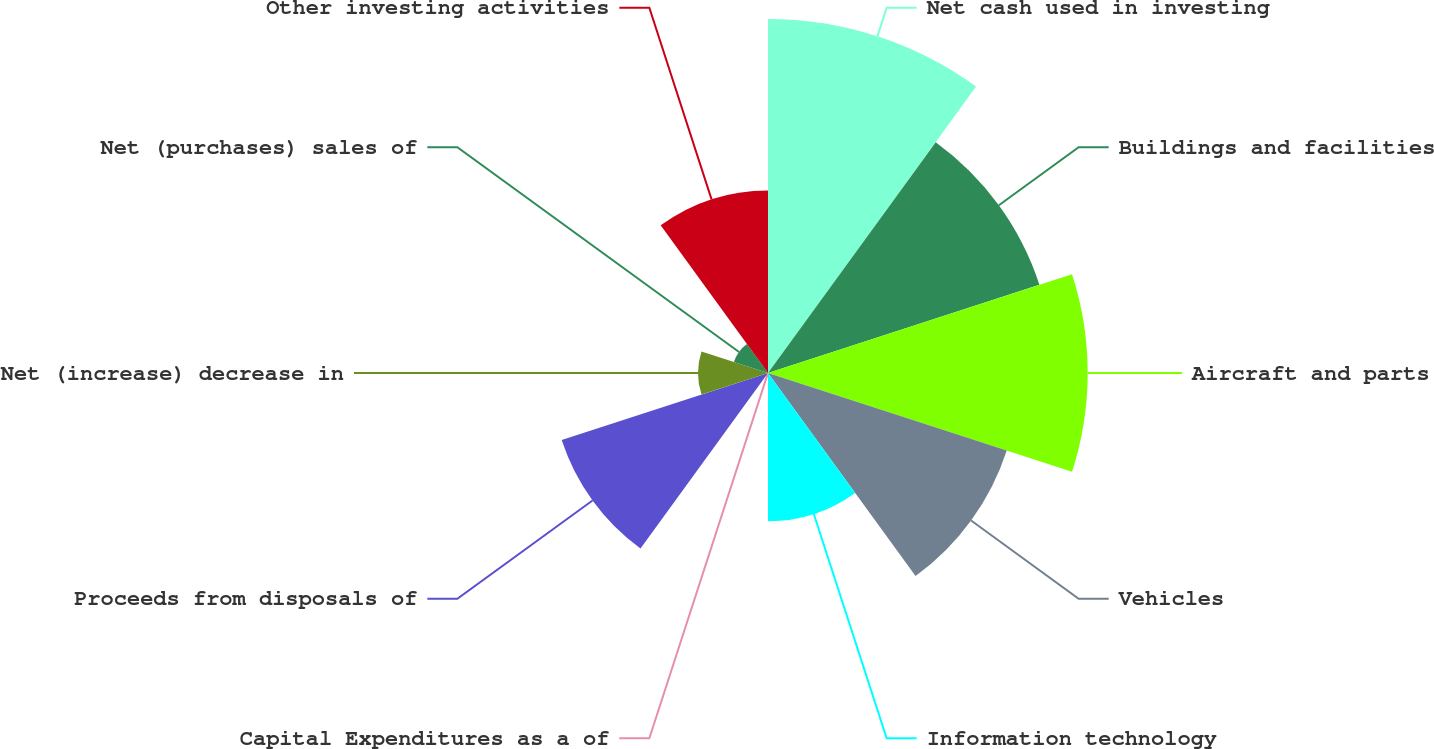Convert chart to OTSL. <chart><loc_0><loc_0><loc_500><loc_500><pie_chart><fcel>Net cash used in investing<fcel>Buildings and facilities<fcel>Aircraft and parts<fcel>Vehicles<fcel>Information technology<fcel>Capital Expenditures as a of<fcel>Proceeds from disposals of<fcel>Net (increase) decrease in<fcel>Net (purchases) sales of<fcel>Other investing activities<nl><fcel>18.98%<fcel>15.3%<fcel>17.14%<fcel>13.46%<fcel>7.95%<fcel>0.08%<fcel>11.63%<fcel>3.75%<fcel>1.92%<fcel>9.79%<nl></chart> 